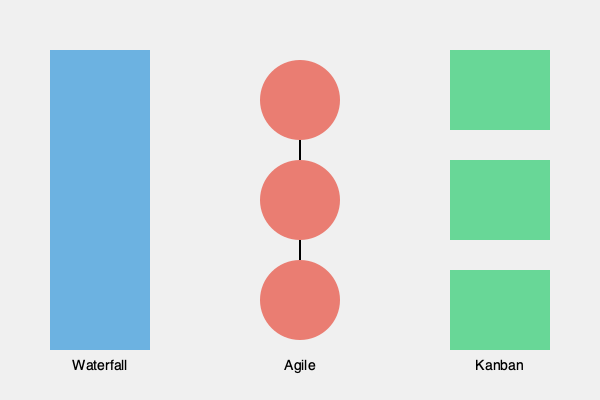Based on the flowcharts representing different project management methodologies, which approach is best suited for a dynamic IT environment where requirements frequently change and continuous delivery is essential? To answer this question, let's analyze each methodology represented in the flowchart:

1. Waterfall (left):
   - Represented by a single, long rectangle
   - Indicates a linear, sequential approach
   - Best for projects with well-defined, stable requirements
   - Less flexible to changes

2. Agile (center):
   - Represented by interconnected circles
   - Indicates an iterative, cyclical approach
   - Allows for frequent reassessment and adaptation
   - Ideal for projects with changing requirements

3. Kanban (right):
   - Represented by separate, equal-sized rectangles
   - Indicates a continuous flow of work items
   - Focuses on visualizing work and limiting work in progress
   - Suitable for ongoing processes with varying priorities

For a dynamic IT environment with frequently changing requirements and a need for continuous delivery:

- Waterfall is too rigid and doesn't accommodate frequent changes well.
- Kanban is good for continuous flow but may not provide enough structure for complex projects.
- Agile stands out as the best fit because:
  a) It allows for iterative development and frequent reassessment.
  b) It can adapt to changing requirements easily.
  c) It supports continuous delivery through short development cycles.

Therefore, the Agile methodology is best suited for the described scenario.
Answer: Agile 